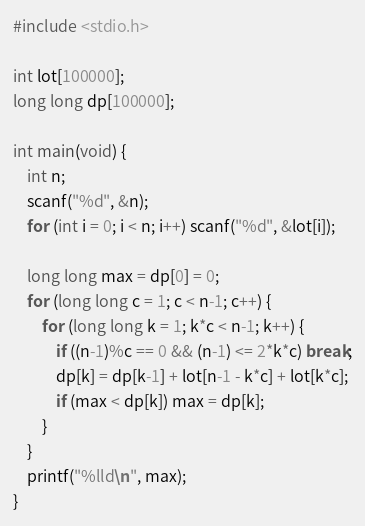<code> <loc_0><loc_0><loc_500><loc_500><_C_>#include <stdio.h>

int lot[100000];
long long dp[100000];

int main(void) {
	int n;
	scanf("%d", &n);
	for (int i = 0; i < n; i++) scanf("%d", &lot[i]);

	long long max = dp[0] = 0;
	for (long long c = 1; c < n-1; c++) {
		for (long long k = 1; k*c < n-1; k++) {
			if ((n-1)%c == 0 && (n-1) <= 2*k*c) break;
			dp[k] = dp[k-1] + lot[n-1 - k*c] + lot[k*c];
			if (max < dp[k]) max = dp[k];
		}
	}
	printf("%lld\n", max);
}
</code> 